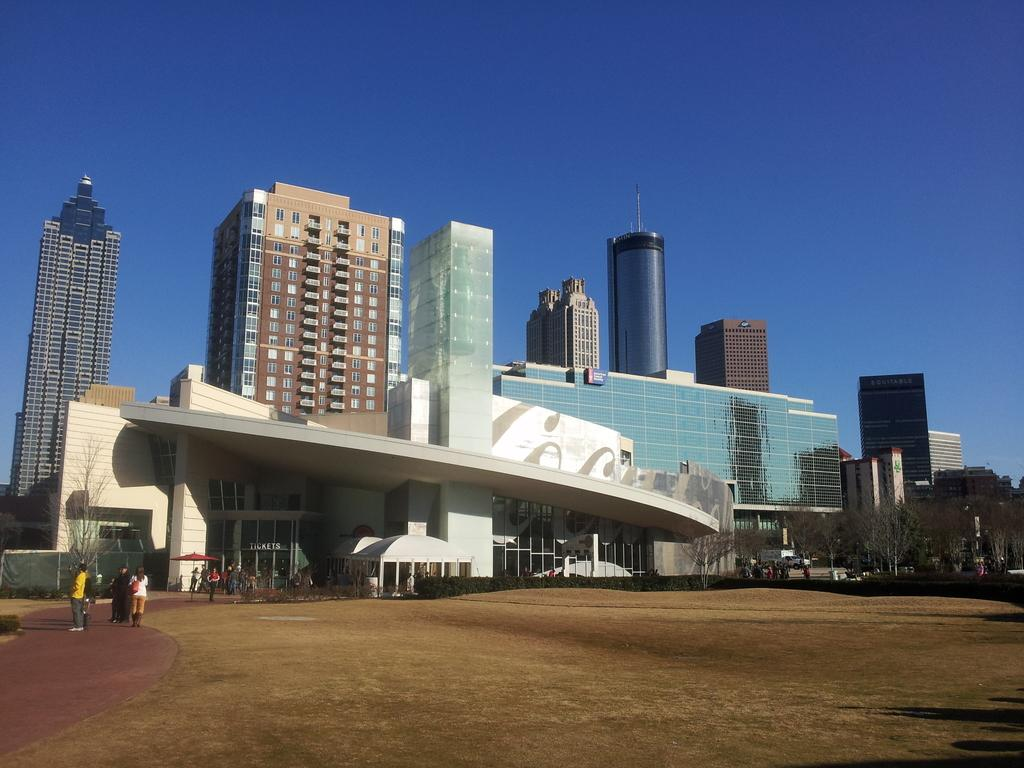What can be seen in the foreground of the image? There is land in the foreground of the image. What are the people in the image doing? The people are standing on the path on the left side of the image. What is visible in the background of the image? There are buildings, trees, and the sky visible in the background of the image. What is the condition of the fifth building in the image? There is no mention of a fifth building in the image, so we cannot determine its condition. How many leaves can be seen on the trees in the image? The provided facts do not mention leaves on the trees, so we cannot determine the number of leaves in the image. 